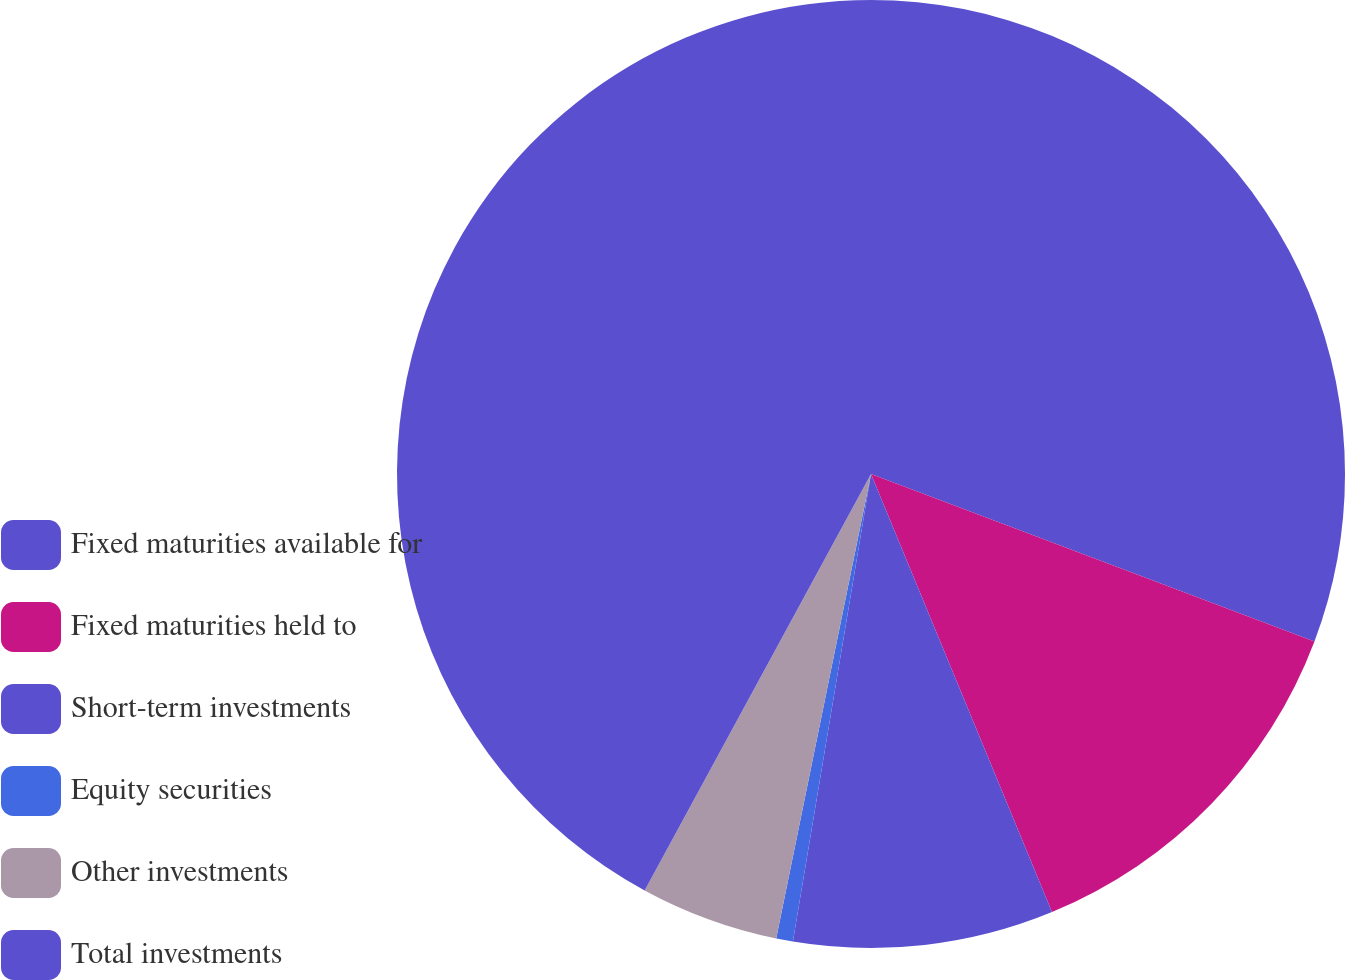<chart> <loc_0><loc_0><loc_500><loc_500><pie_chart><fcel>Fixed maturities available for<fcel>Fixed maturities held to<fcel>Short-term investments<fcel>Equity securities<fcel>Other investments<fcel>Total investments<nl><fcel>30.75%<fcel>13.02%<fcel>8.87%<fcel>0.57%<fcel>4.72%<fcel>42.08%<nl></chart> 